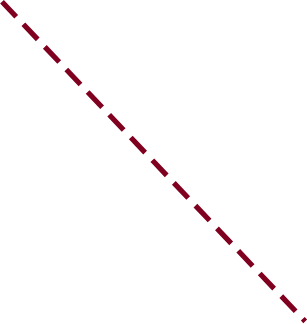<chart> <loc_0><loc_0><loc_500><loc_500><line_chart><ecel><fcel>Unnamed: 1<nl><fcel>1966.49<fcel>12660.1<nl><fcel>2031.07<fcel>7666.13<nl><fcel>2239.11<fcel>3312.35<nl></chart> 